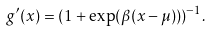<formula> <loc_0><loc_0><loc_500><loc_500>g ^ { \prime } ( x ) = ( 1 + \exp ( \beta ( x - \mu ) ) ) ^ { - 1 } .</formula> 